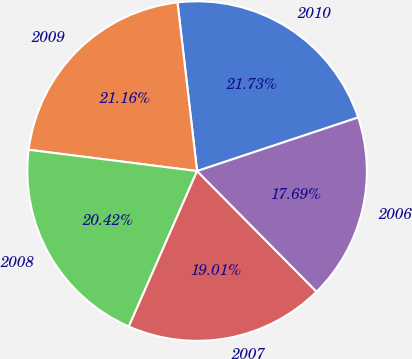<chart> <loc_0><loc_0><loc_500><loc_500><pie_chart><fcel>2010<fcel>2009<fcel>2008<fcel>2007<fcel>2006<nl><fcel>21.73%<fcel>21.16%<fcel>20.42%<fcel>19.01%<fcel>17.69%<nl></chart> 